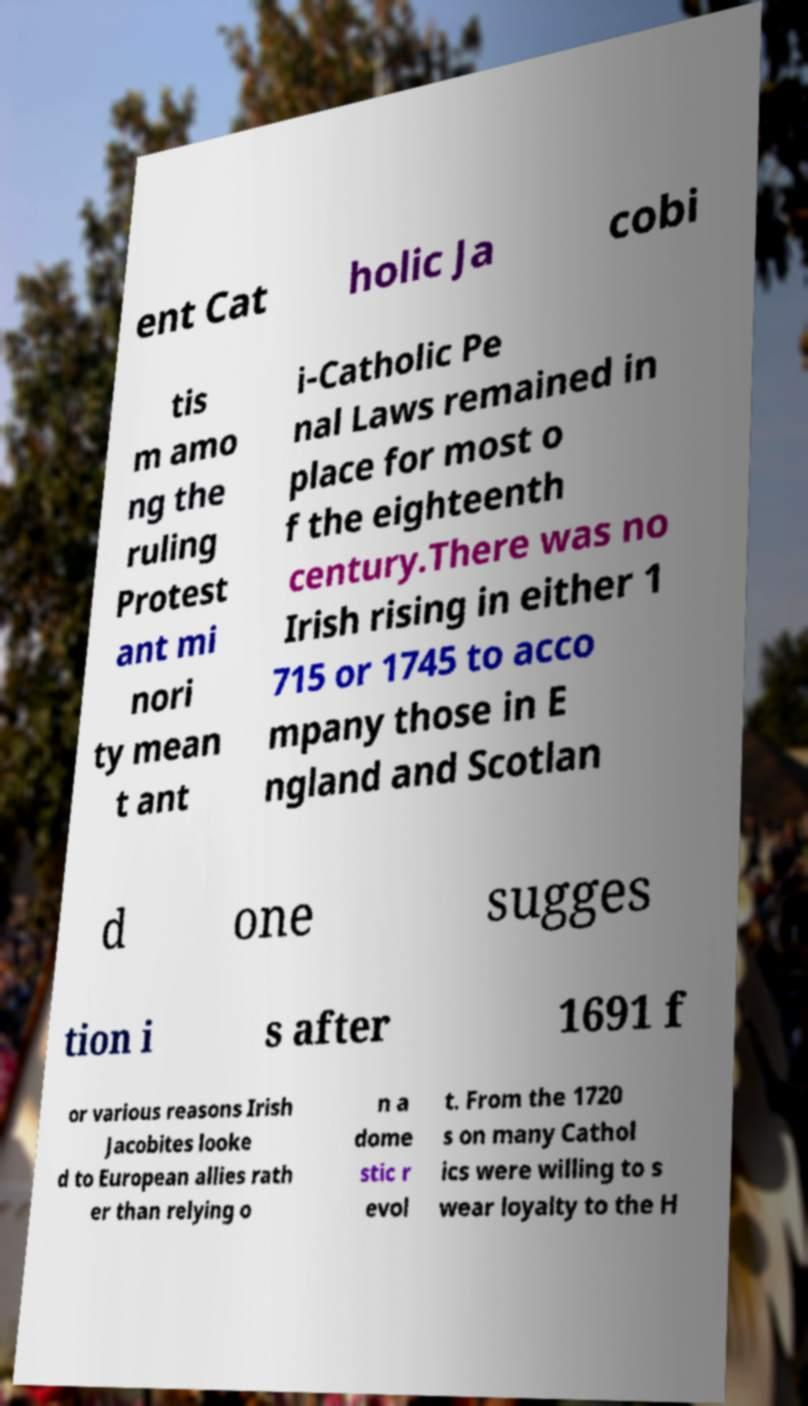What messages or text are displayed in this image? I need them in a readable, typed format. ent Cat holic Ja cobi tis m amo ng the ruling Protest ant mi nori ty mean t ant i-Catholic Pe nal Laws remained in place for most o f the eighteenth century.There was no Irish rising in either 1 715 or 1745 to acco mpany those in E ngland and Scotlan d one sugges tion i s after 1691 f or various reasons Irish Jacobites looke d to European allies rath er than relying o n a dome stic r evol t. From the 1720 s on many Cathol ics were willing to s wear loyalty to the H 